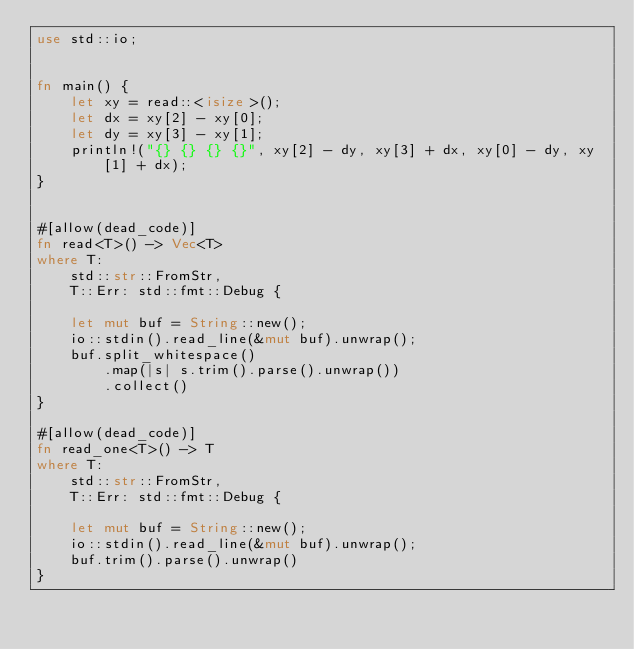<code> <loc_0><loc_0><loc_500><loc_500><_Rust_>use std::io;


fn main() {
    let xy = read::<isize>();
    let dx = xy[2] - xy[0];
    let dy = xy[3] - xy[1];
    println!("{} {} {} {}", xy[2] - dy, xy[3] + dx, xy[0] - dy, xy[1] + dx);
}


#[allow(dead_code)]
fn read<T>() -> Vec<T>
where T:
    std::str::FromStr,
    T::Err: std::fmt::Debug {

    let mut buf = String::new();
    io::stdin().read_line(&mut buf).unwrap();
    buf.split_whitespace()
        .map(|s| s.trim().parse().unwrap())
        .collect()
}

#[allow(dead_code)]
fn read_one<T>() -> T
where T:
    std::str::FromStr,
    T::Err: std::fmt::Debug {

    let mut buf = String::new();
    io::stdin().read_line(&mut buf).unwrap();
    buf.trim().parse().unwrap()
}</code> 